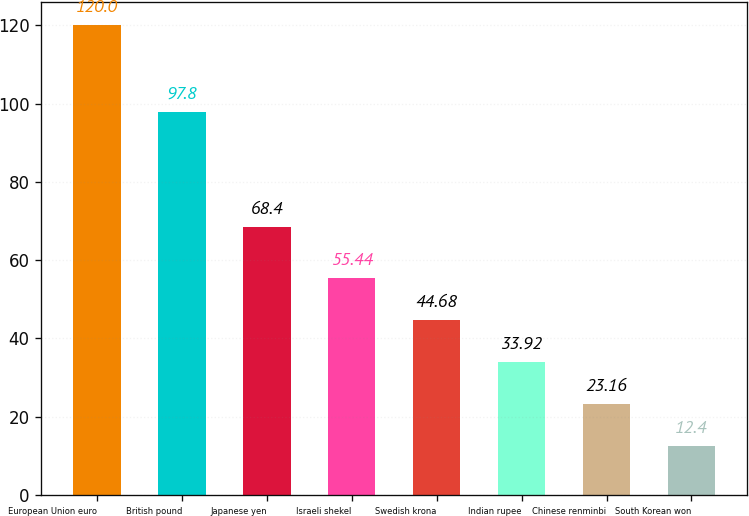Convert chart. <chart><loc_0><loc_0><loc_500><loc_500><bar_chart><fcel>European Union euro<fcel>British pound<fcel>Japanese yen<fcel>Israeli shekel<fcel>Swedish krona<fcel>Indian rupee<fcel>Chinese renminbi<fcel>South Korean won<nl><fcel>120<fcel>97.8<fcel>68.4<fcel>55.44<fcel>44.68<fcel>33.92<fcel>23.16<fcel>12.4<nl></chart> 